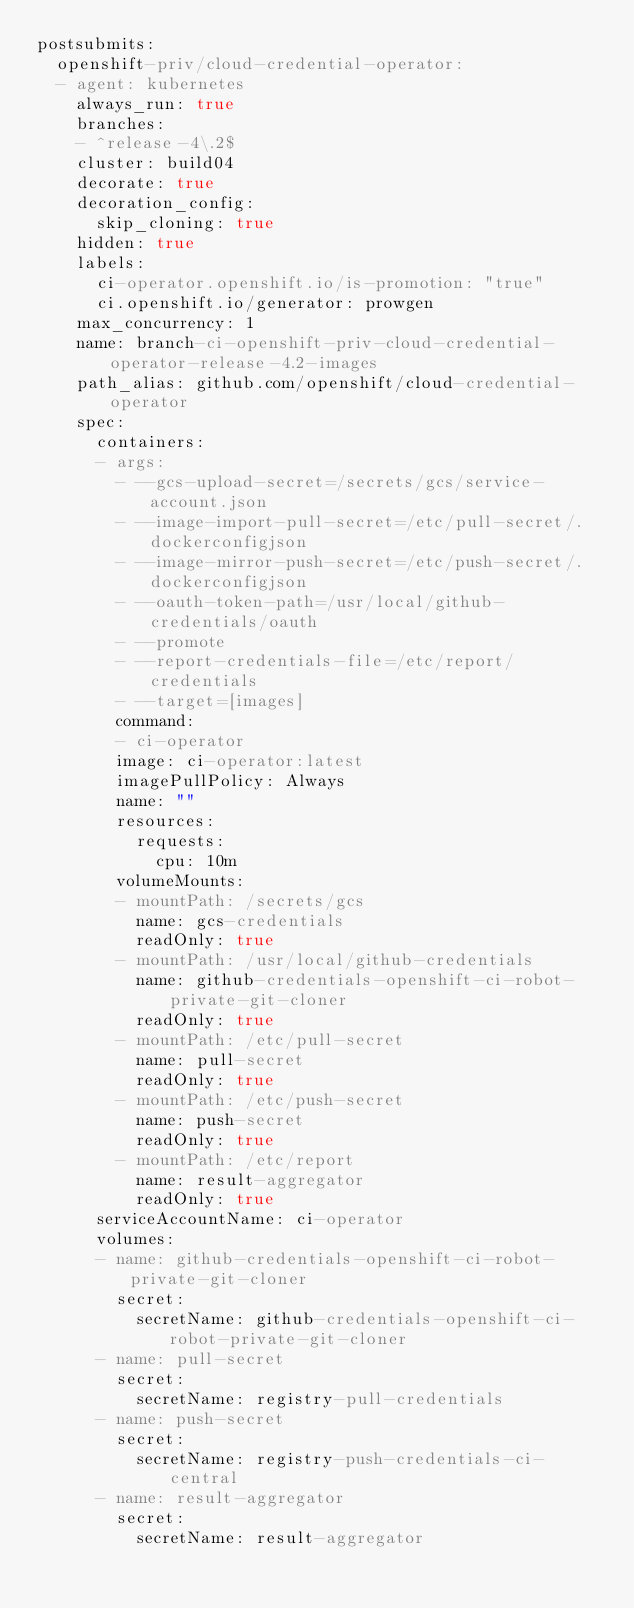Convert code to text. <code><loc_0><loc_0><loc_500><loc_500><_YAML_>postsubmits:
  openshift-priv/cloud-credential-operator:
  - agent: kubernetes
    always_run: true
    branches:
    - ^release-4\.2$
    cluster: build04
    decorate: true
    decoration_config:
      skip_cloning: true
    hidden: true
    labels:
      ci-operator.openshift.io/is-promotion: "true"
      ci.openshift.io/generator: prowgen
    max_concurrency: 1
    name: branch-ci-openshift-priv-cloud-credential-operator-release-4.2-images
    path_alias: github.com/openshift/cloud-credential-operator
    spec:
      containers:
      - args:
        - --gcs-upload-secret=/secrets/gcs/service-account.json
        - --image-import-pull-secret=/etc/pull-secret/.dockerconfigjson
        - --image-mirror-push-secret=/etc/push-secret/.dockerconfigjson
        - --oauth-token-path=/usr/local/github-credentials/oauth
        - --promote
        - --report-credentials-file=/etc/report/credentials
        - --target=[images]
        command:
        - ci-operator
        image: ci-operator:latest
        imagePullPolicy: Always
        name: ""
        resources:
          requests:
            cpu: 10m
        volumeMounts:
        - mountPath: /secrets/gcs
          name: gcs-credentials
          readOnly: true
        - mountPath: /usr/local/github-credentials
          name: github-credentials-openshift-ci-robot-private-git-cloner
          readOnly: true
        - mountPath: /etc/pull-secret
          name: pull-secret
          readOnly: true
        - mountPath: /etc/push-secret
          name: push-secret
          readOnly: true
        - mountPath: /etc/report
          name: result-aggregator
          readOnly: true
      serviceAccountName: ci-operator
      volumes:
      - name: github-credentials-openshift-ci-robot-private-git-cloner
        secret:
          secretName: github-credentials-openshift-ci-robot-private-git-cloner
      - name: pull-secret
        secret:
          secretName: registry-pull-credentials
      - name: push-secret
        secret:
          secretName: registry-push-credentials-ci-central
      - name: result-aggregator
        secret:
          secretName: result-aggregator
</code> 